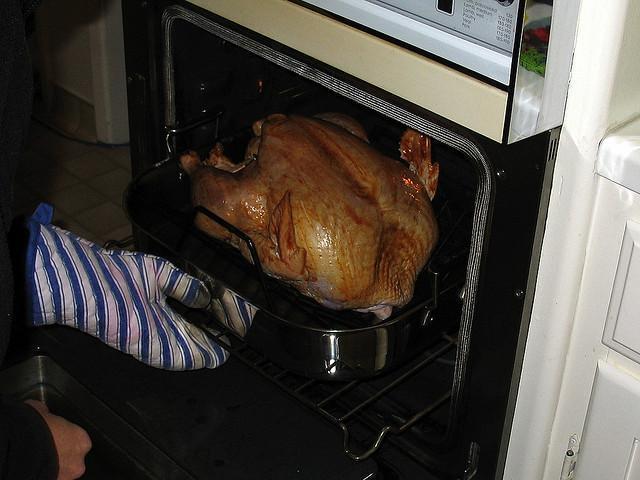How many human hands are in the scene?
Give a very brief answer. 1. 